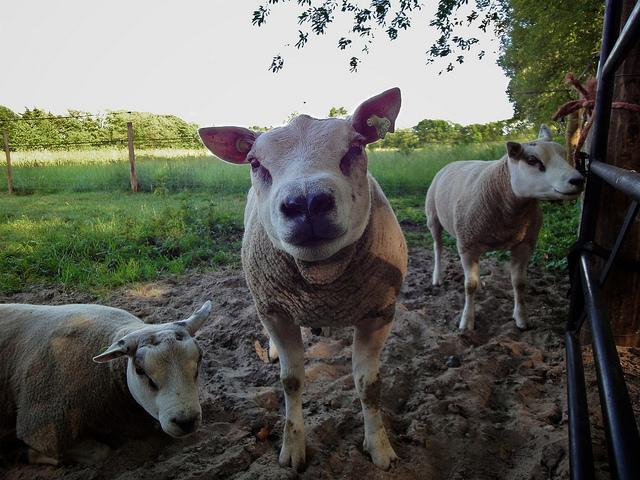Which indoor domestic animal does the center sheep resemble?

Choices:
A) bull terrier
B) reptile
C) cat
D) fish bull terrier 